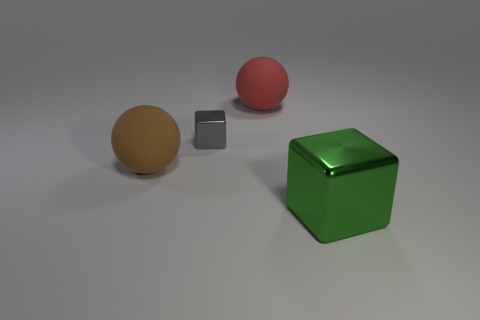Is the number of red rubber things that are to the left of the small object the same as the number of green cylinders?
Your answer should be compact. Yes. There is a object that is both in front of the red object and behind the large brown matte sphere; what size is it?
Keep it short and to the point. Small. Are there any other things that are the same color as the large cube?
Offer a very short reply. No. How big is the thing on the right side of the big ball to the right of the gray metallic block?
Ensure brevity in your answer.  Large. The big thing that is to the right of the big brown object and in front of the red rubber thing is what color?
Give a very brief answer. Green. How many other things are the same size as the green shiny block?
Keep it short and to the point. 2. There is a gray metallic thing; does it have the same size as the matte ball that is left of the red sphere?
Ensure brevity in your answer.  No. What color is the metal object that is the same size as the red rubber sphere?
Your response must be concise. Green. How big is the brown sphere?
Make the answer very short. Large. Do the cube that is behind the big cube and the green object have the same material?
Keep it short and to the point. Yes. 